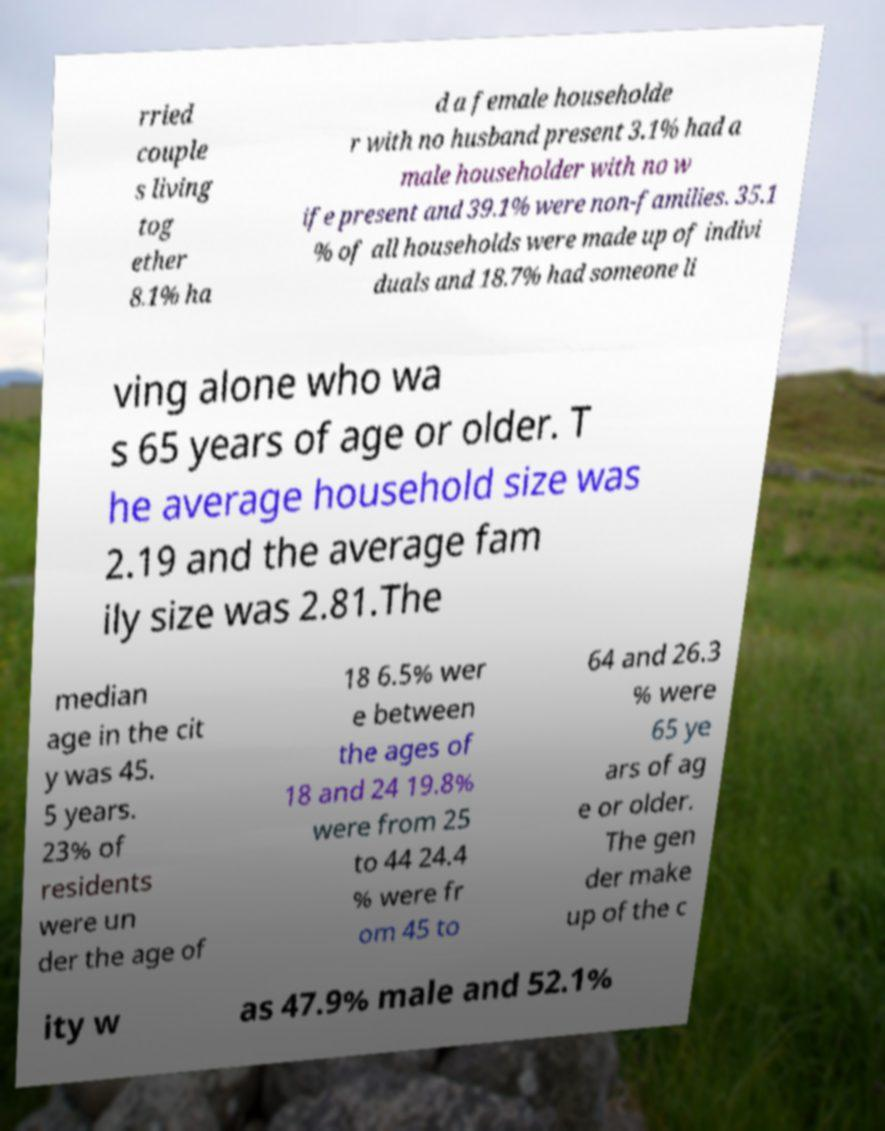Please read and relay the text visible in this image. What does it say? rried couple s living tog ether 8.1% ha d a female householde r with no husband present 3.1% had a male householder with no w ife present and 39.1% were non-families. 35.1 % of all households were made up of indivi duals and 18.7% had someone li ving alone who wa s 65 years of age or older. T he average household size was 2.19 and the average fam ily size was 2.81.The median age in the cit y was 45. 5 years. 23% of residents were un der the age of 18 6.5% wer e between the ages of 18 and 24 19.8% were from 25 to 44 24.4 % were fr om 45 to 64 and 26.3 % were 65 ye ars of ag e or older. The gen der make up of the c ity w as 47.9% male and 52.1% 